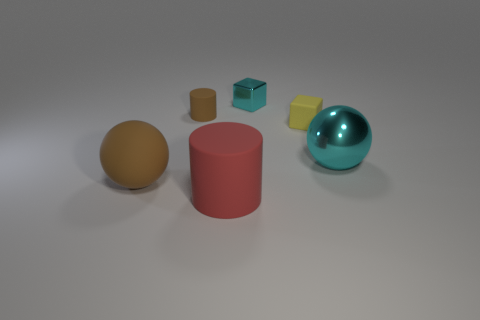Add 3 brown spheres. How many objects exist? 9 Subtract all blocks. How many objects are left? 4 Add 3 large rubber balls. How many large rubber balls are left? 4 Add 6 cyan spheres. How many cyan spheres exist? 7 Subtract 0 yellow balls. How many objects are left? 6 Subtract all large things. Subtract all tiny cyan things. How many objects are left? 2 